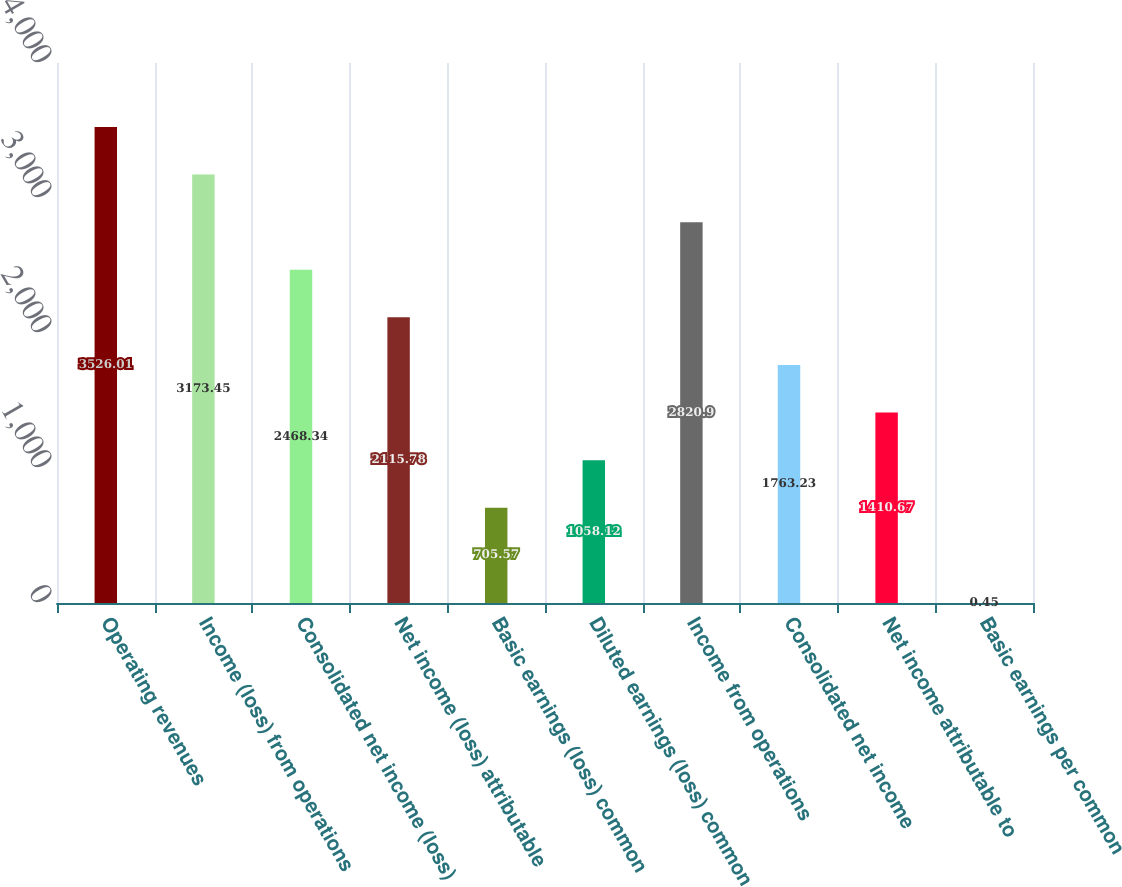Convert chart to OTSL. <chart><loc_0><loc_0><loc_500><loc_500><bar_chart><fcel>Operating revenues<fcel>Income (loss) from operations<fcel>Consolidated net income (loss)<fcel>Net income (loss) attributable<fcel>Basic earnings (loss) common<fcel>Diluted earnings (loss) common<fcel>Income from operations<fcel>Consolidated net income<fcel>Net income attributable to<fcel>Basic earnings per common<nl><fcel>3526.01<fcel>3173.45<fcel>2468.34<fcel>2115.78<fcel>705.57<fcel>1058.12<fcel>2820.9<fcel>1763.23<fcel>1410.67<fcel>0.45<nl></chart> 